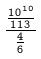Convert formula to latex. <formula><loc_0><loc_0><loc_500><loc_500>\frac { \frac { 1 0 ^ { 1 0 } } { 1 1 3 } } { \frac { 4 } { 6 } }</formula> 